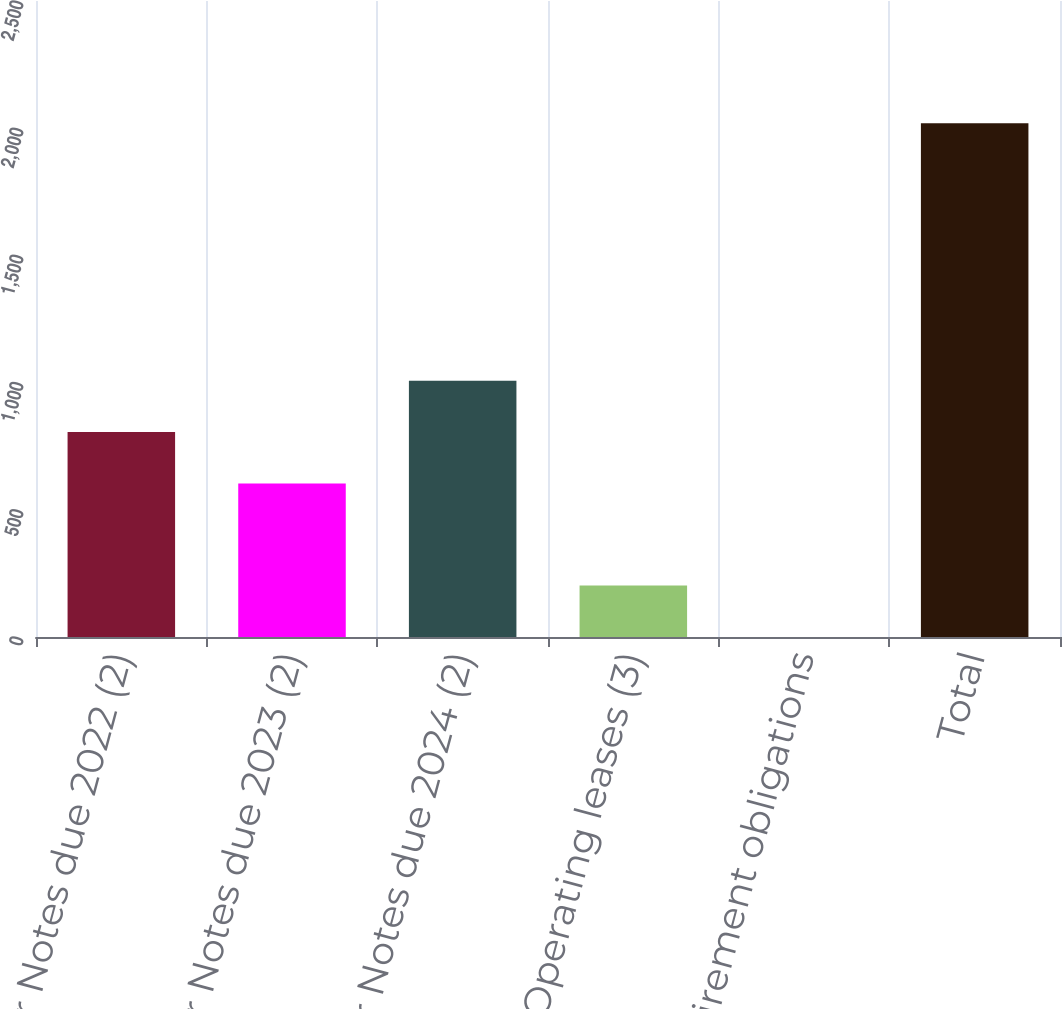Convert chart. <chart><loc_0><loc_0><loc_500><loc_500><bar_chart><fcel>Senior Notes due 2022 (2)<fcel>Senior Notes due 2023 (2)<fcel>Senior Notes due 2024 (2)<fcel>Operating leases (3)<fcel>Asset retirement obligations<fcel>Total<nl><fcel>805.72<fcel>603.8<fcel>1007.64<fcel>202.12<fcel>0.2<fcel>2019.4<nl></chart> 